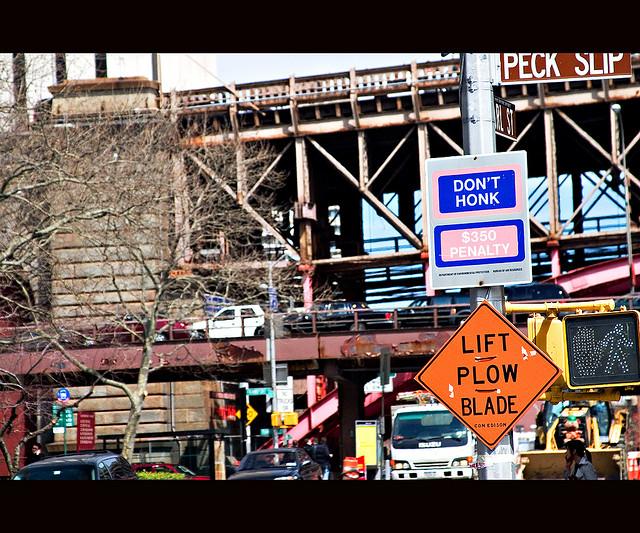What does the yellow sign say?
Concise answer only. Lift plow blade. How many people are in their vehicles?
Write a very short answer. 3. What is the penalty for honking?
Keep it brief. $350. 